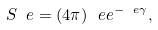<formula> <loc_0><loc_0><loc_500><loc_500>S _ { \ } e = ( 4 \pi ) ^ { \ } e e ^ { - \ e \gamma } ,</formula> 